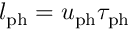<formula> <loc_0><loc_0><loc_500><loc_500>l _ { p h } = u _ { p h } \tau _ { p h }</formula> 